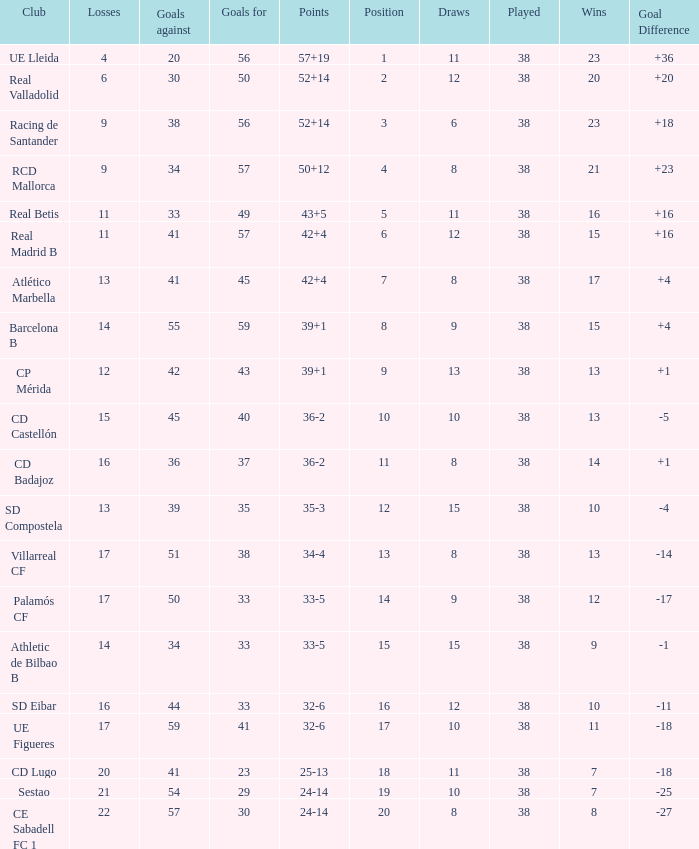What is the highest number of wins with a goal difference less than 4 at the Villarreal CF and more than 38 played? None. 